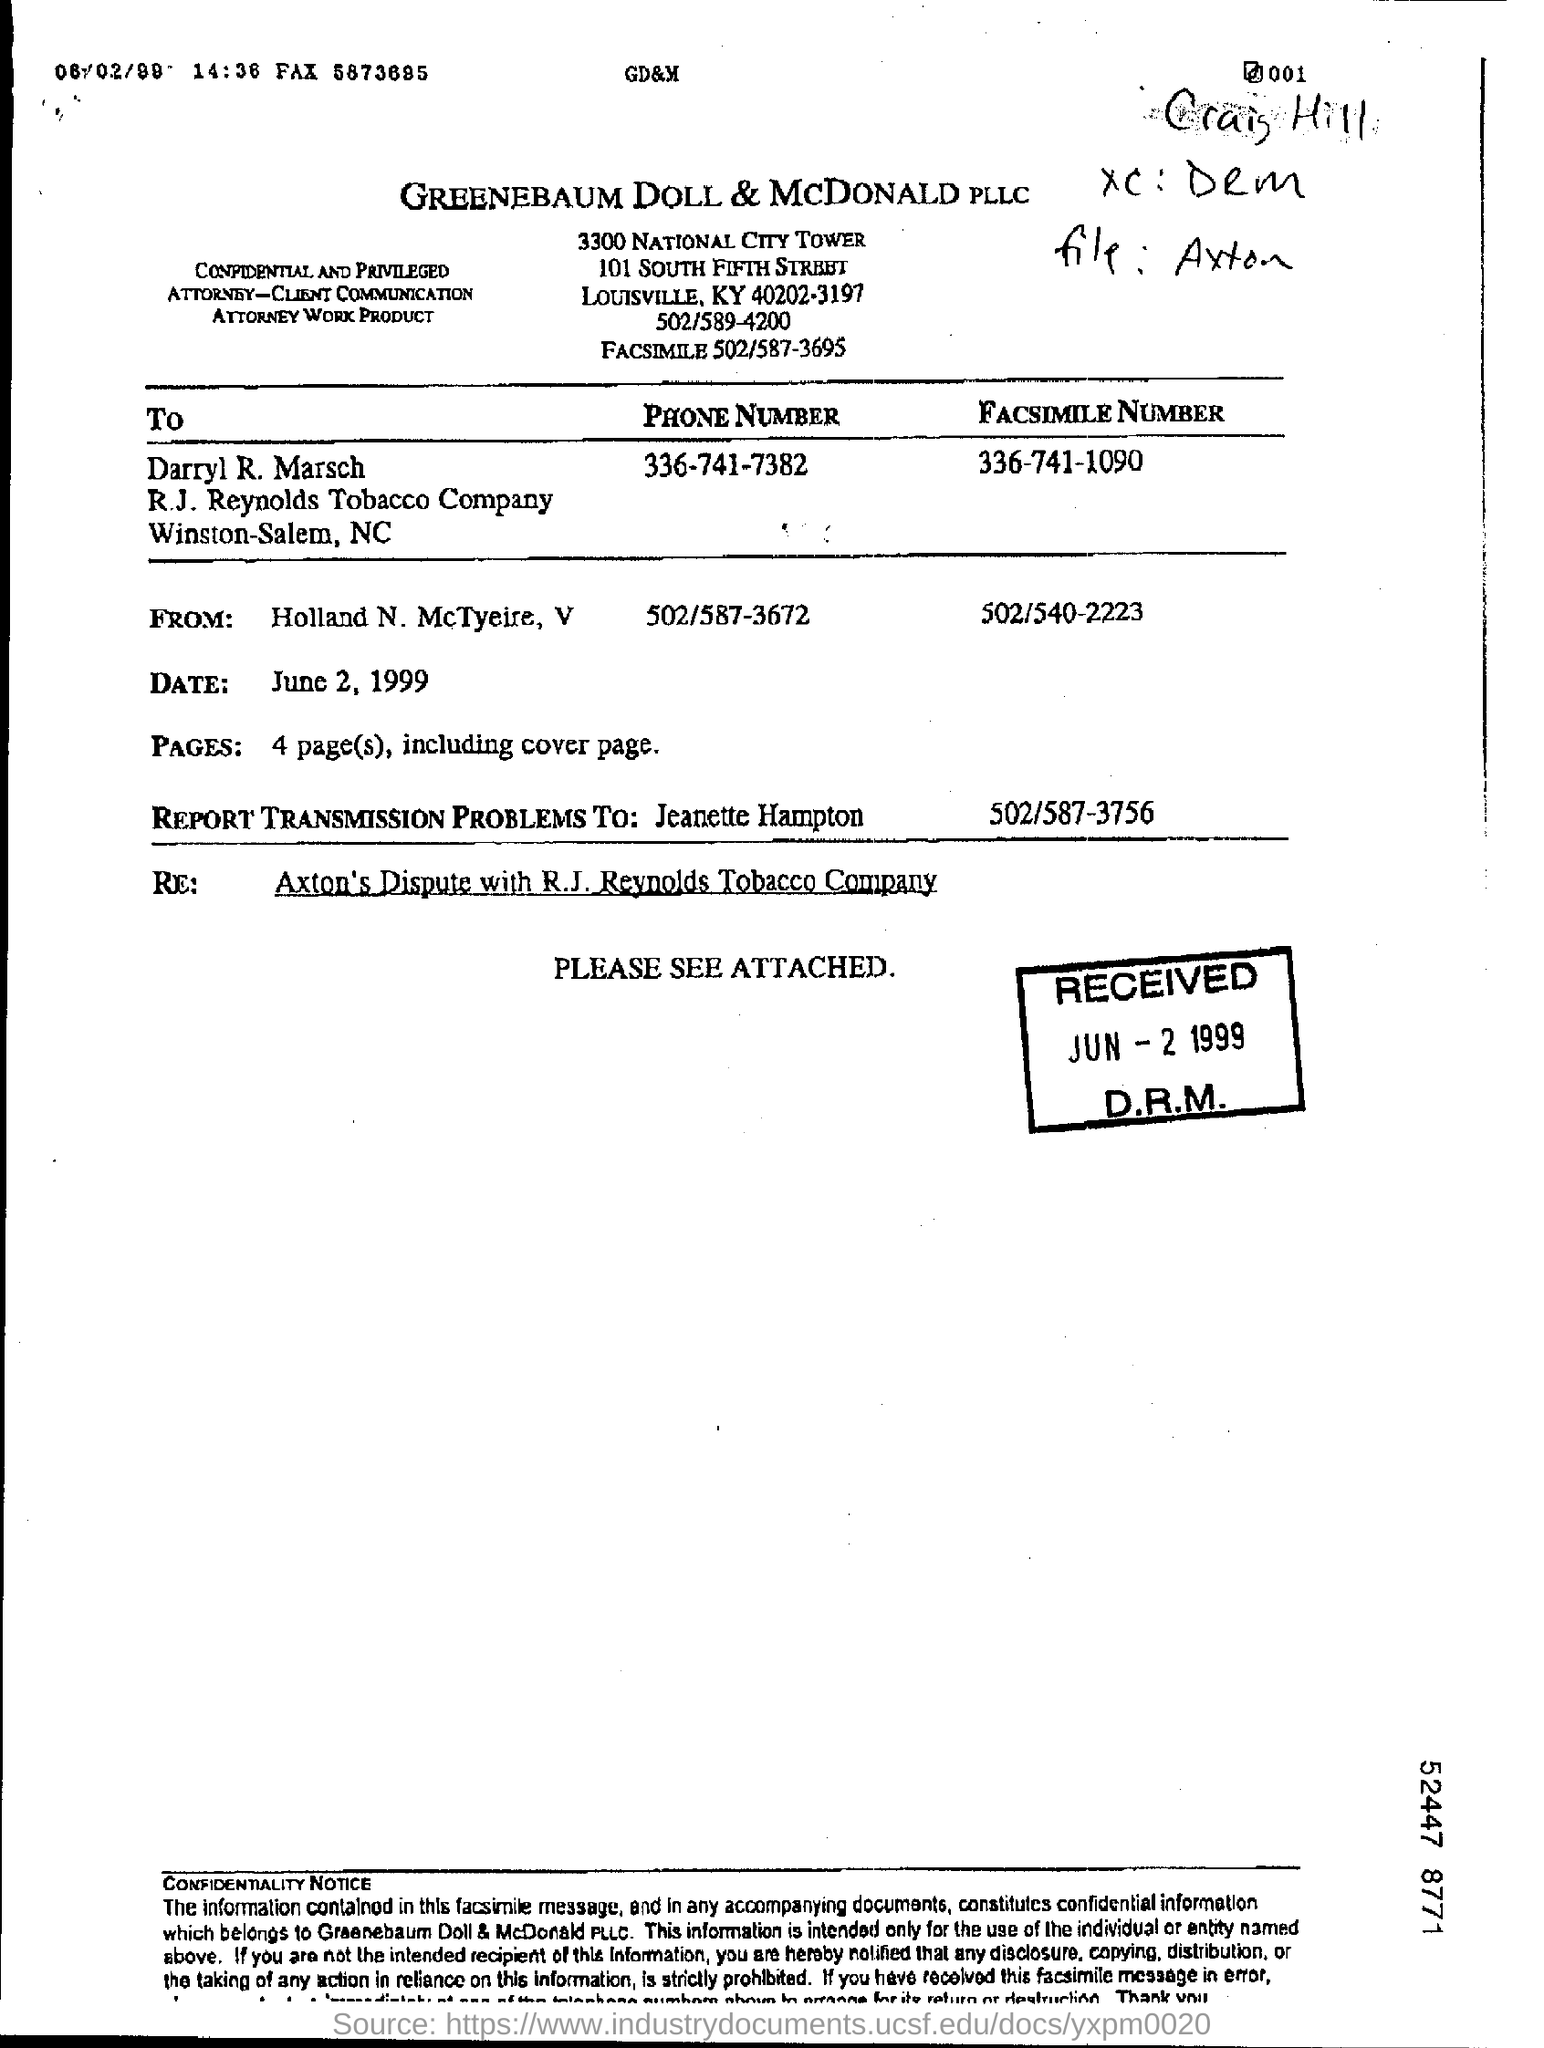What is the company name on the document
Provide a short and direct response. GREENEBAUM DOLL & MCDONALD PLLC. 